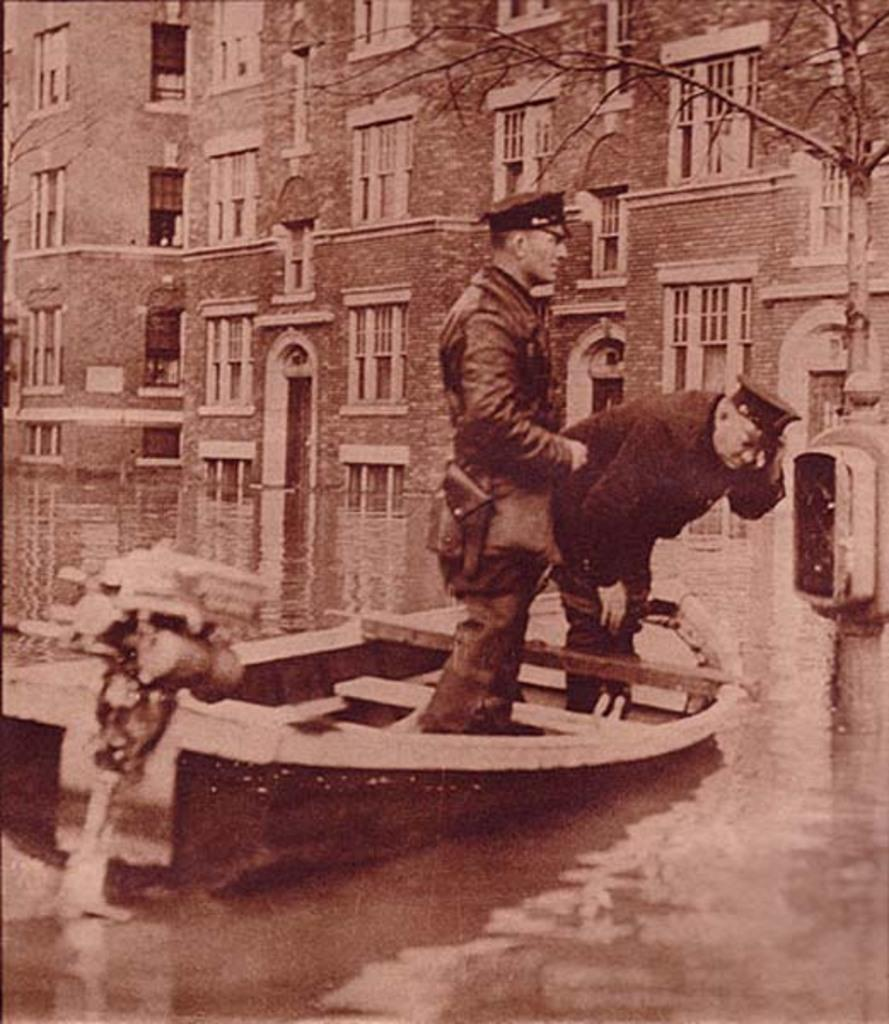What is in the foreground of the picture? There is a water body in the foreground of the picture. What is located in the water? There is a boat in the water. How many people are in the boat? There are two persons in the boat. What can be seen in the background of the picture? There are buildings and a tree in the background of the picture. Can you see any deer in the image? There are no deer present in the image. What color is the toe of the person in the boat? There is no visible toe of the person in the boat in the image. 